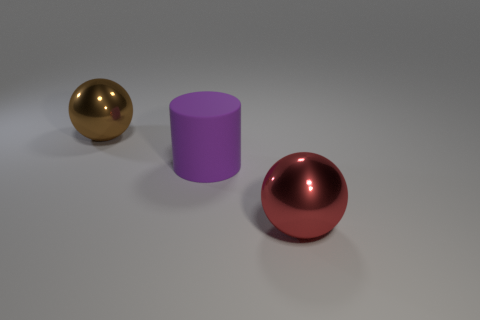Is the number of small gray matte things greater than the number of brown spheres?
Ensure brevity in your answer.  No. Are there any other things that have the same color as the large rubber cylinder?
Make the answer very short. No. What is the size of the other sphere that is the same material as the brown ball?
Offer a very short reply. Large. What is the material of the cylinder?
Your response must be concise. Rubber. How many purple matte things are the same size as the brown object?
Your answer should be compact. 1. Are there any other large matte things of the same shape as the purple rubber thing?
Give a very brief answer. No. What color is the rubber cylinder that is the same size as the brown shiny ball?
Provide a short and direct response. Purple. What color is the shiny object that is in front of the metal object to the left of the red shiny thing?
Give a very brief answer. Red. Does the big ball that is behind the rubber thing have the same color as the big rubber cylinder?
Ensure brevity in your answer.  No. What shape is the large metal thing that is to the right of the large metal thing that is behind the big ball on the right side of the brown ball?
Your response must be concise. Sphere. 